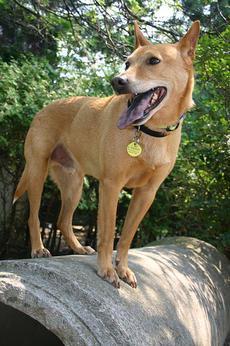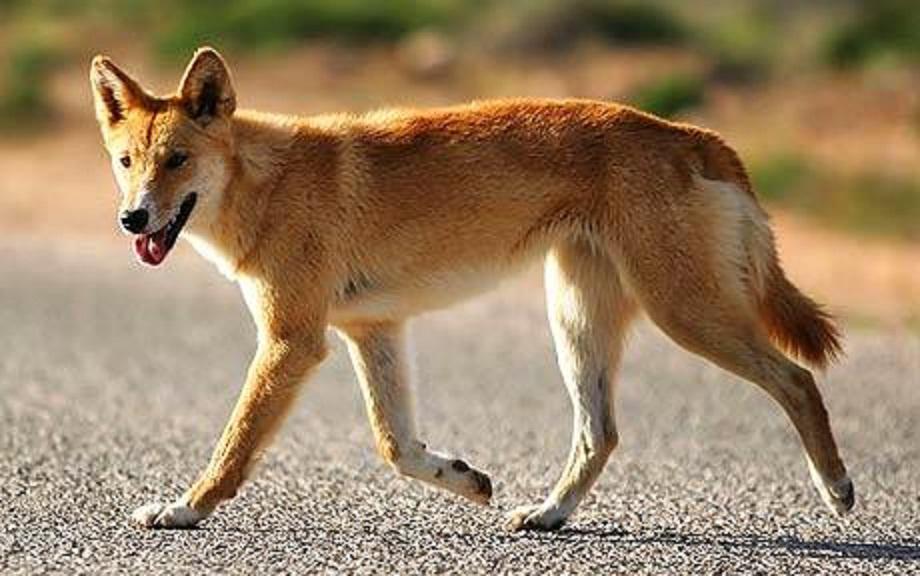The first image is the image on the left, the second image is the image on the right. Assess this claim about the two images: "At least one image features multiple dogs.". Correct or not? Answer yes or no. No. 